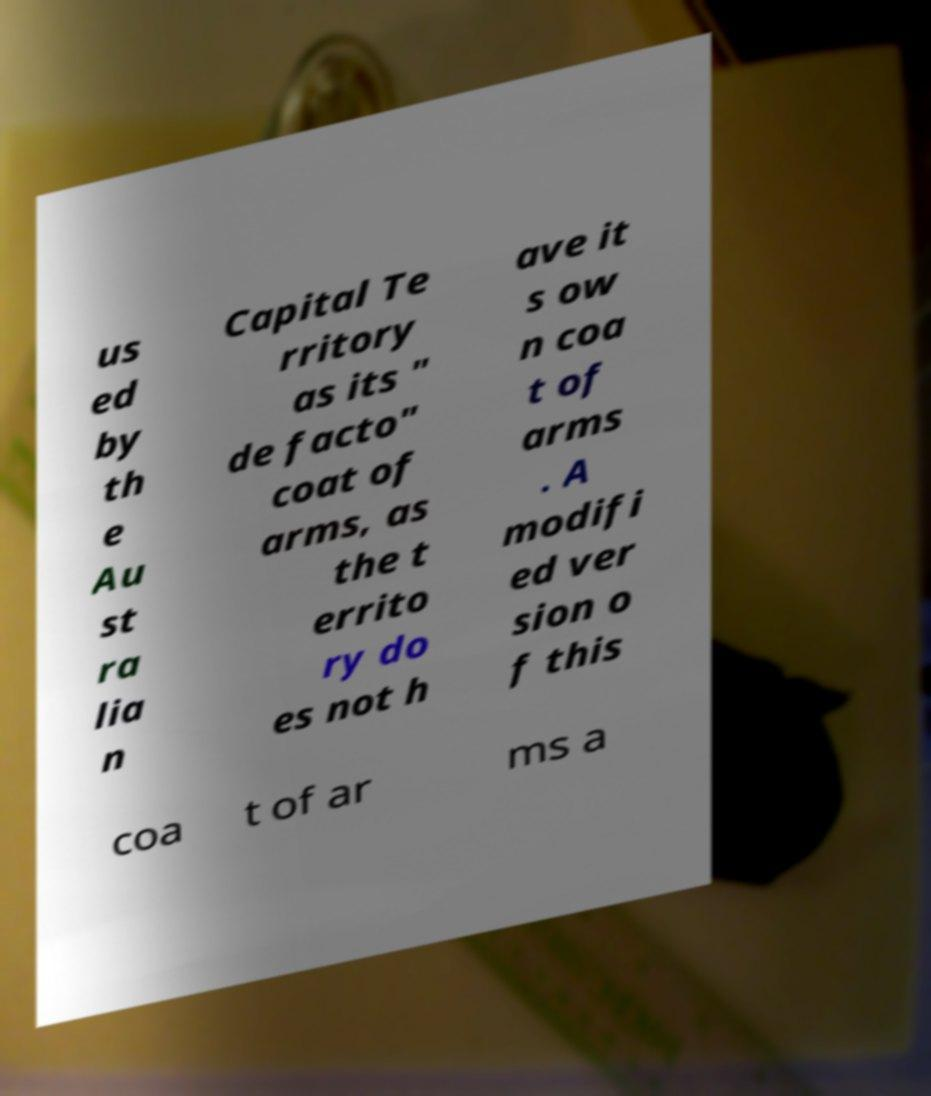What messages or text are displayed in this image? I need them in a readable, typed format. us ed by th e Au st ra lia n Capital Te rritory as its " de facto" coat of arms, as the t errito ry do es not h ave it s ow n coa t of arms . A modifi ed ver sion o f this coa t of ar ms a 